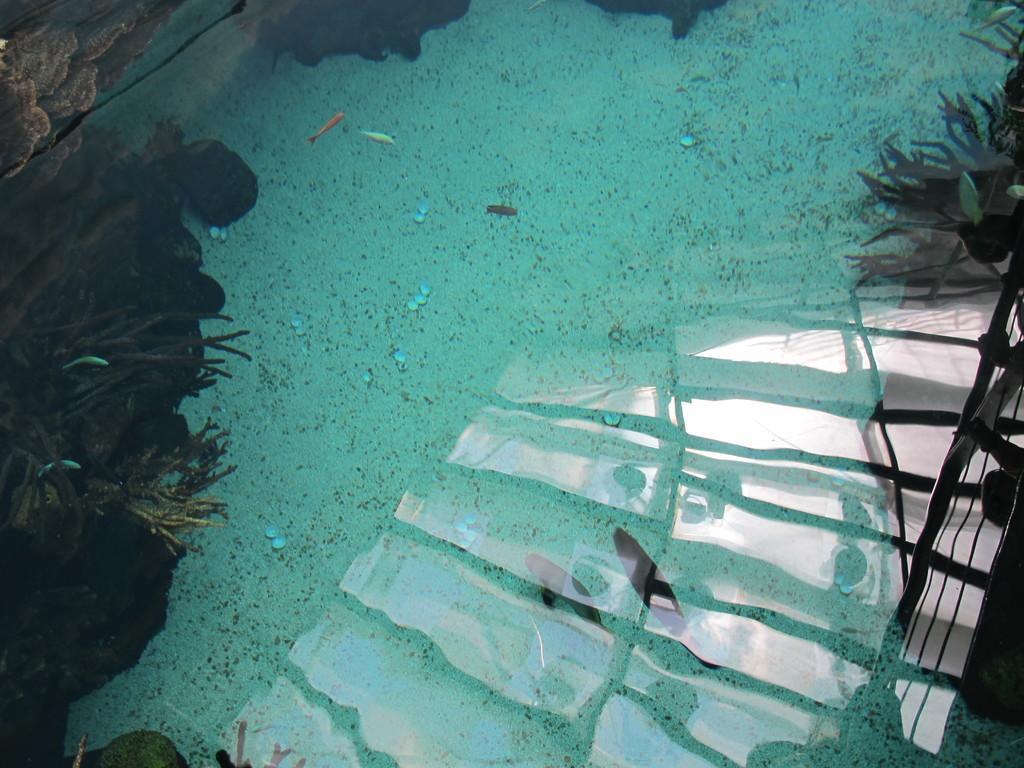How would you summarize this image in a sentence or two? In this image there is a pool with water, a few fishes and a few water plants in it. 